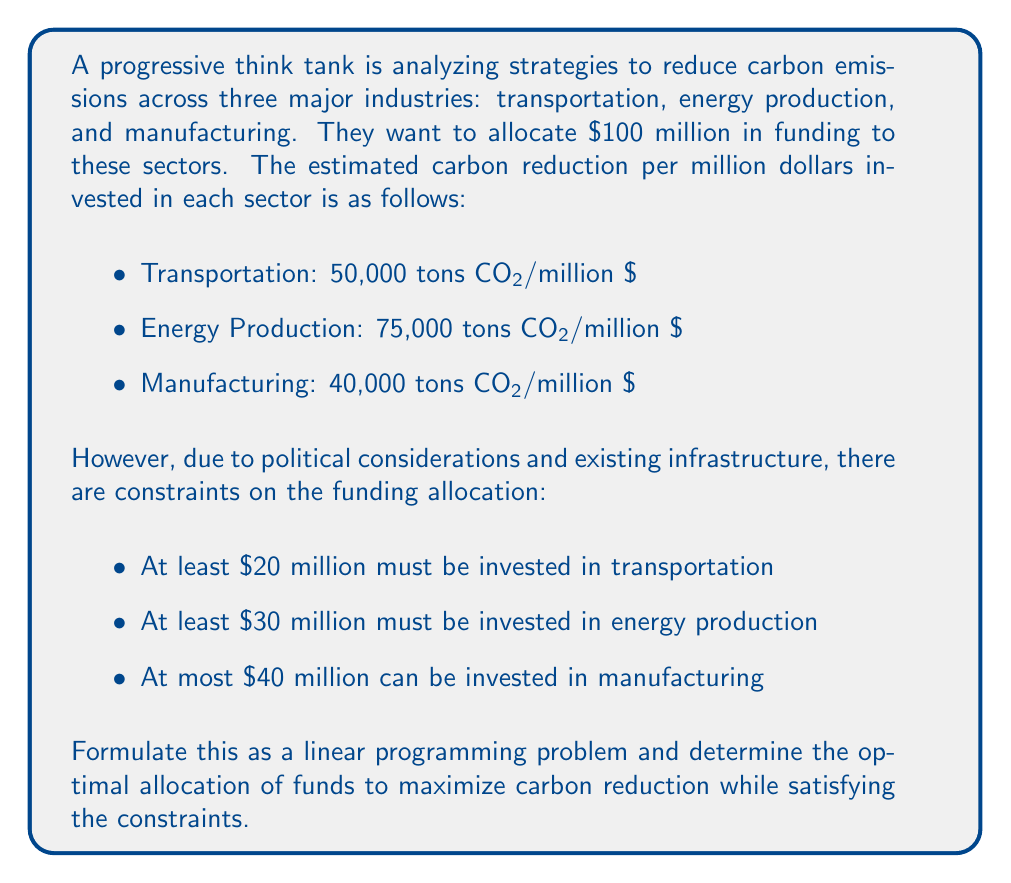Show me your answer to this math problem. To formulate this as a linear programming problem, we need to define our decision variables, objective function, and constraints.

Let:
$x_1$ = amount invested in transportation (millions $)
$x_2$ = amount invested in energy production (millions $)
$x_3$ = amount invested in manufacturing (millions $)

Objective function (maximize carbon reduction):
$$\text{Maximize } Z = 50000x_1 + 75000x_2 + 40000x_3$$

Constraints:
1. Total budget constraint: $x_1 + x_2 + x_3 \leq 100$
2. Minimum investment in transportation: $x_1 \geq 20$
3. Minimum investment in energy production: $x_2 \geq 30$
4. Maximum investment in manufacturing: $x_3 \leq 40$
5. Non-negativity constraints: $x_1, x_2, x_3 \geq 0$

To solve this problem, we can use the simplex method or utilize linear programming software. However, we can also reason through the solution:

1. Given the constraints, we must invest at least $20 million in transportation and $30 million in energy production.
2. Energy production has the highest carbon reduction per dollar, so we should maximize investment there after meeting the minimum constraint.
3. Manufacturing has the lowest carbon reduction per dollar, so we should only invest the remaining funds there after maximizing investments in energy production and meeting the minimum constraint for transportation.

Therefore, the optimal solution is:
- Invest $30 million in transportation (meeting the minimum constraint)
- Invest $70 million in energy production (maximizing this highest-return sector)
- Invest $0 in manufacturing

We can verify that this solution meets all constraints:
- Total investment: $30 + $70 + $0 = $100 million (meets budget constraint)
- Transportation investment ≥ $20 million (meets minimum constraint)
- Energy production investment ≥ $30 million (meets minimum constraint)
- Manufacturing investment ≤ $40 million (meets maximum constraint)

The total carbon reduction with this allocation is:
$$(50000 \times 30) + (75000 \times 70) + (40000 \times 0) = 6,750,000 \text{ tons CO2}$$
Answer: The optimal allocation to maximize carbon reduction is:
- Transportation: $30 million
- Energy Production: $70 million
- Manufacturing: $0 million

This allocation results in a total carbon reduction of 6,750,000 tons CO2. 